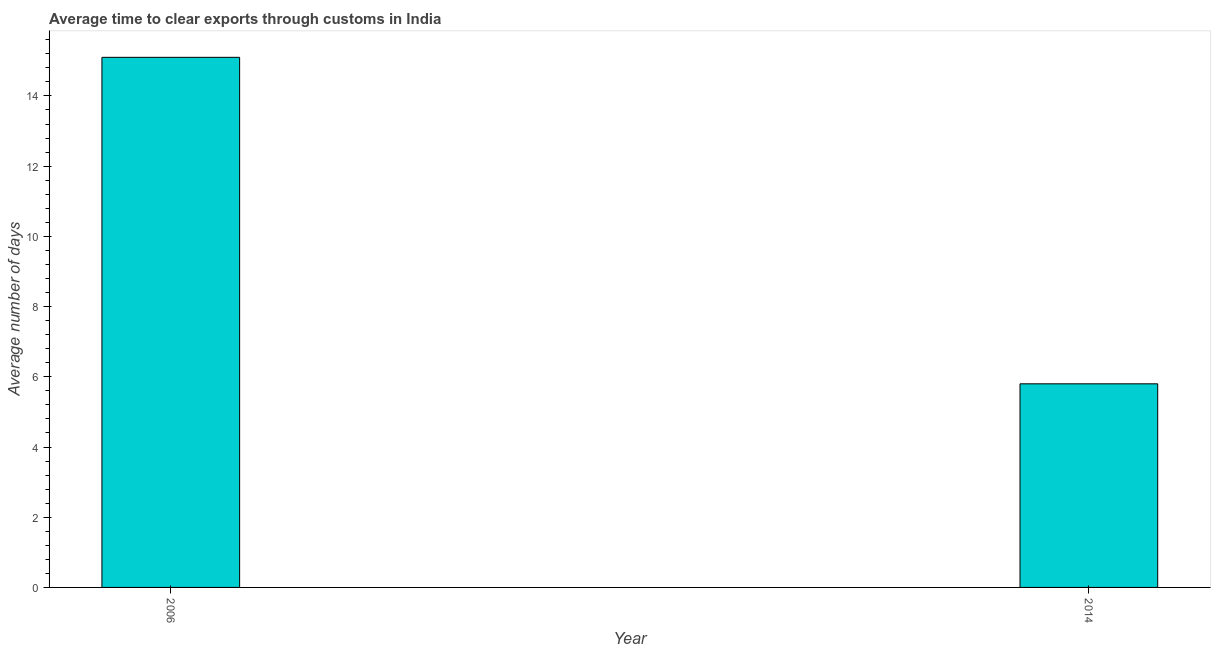Does the graph contain any zero values?
Your response must be concise. No. What is the title of the graph?
Your answer should be very brief. Average time to clear exports through customs in India. What is the label or title of the X-axis?
Keep it short and to the point. Year. What is the label or title of the Y-axis?
Your answer should be very brief. Average number of days. In which year was the time to clear exports through customs maximum?
Provide a succinct answer. 2006. In which year was the time to clear exports through customs minimum?
Offer a terse response. 2014. What is the sum of the time to clear exports through customs?
Your answer should be compact. 20.9. What is the difference between the time to clear exports through customs in 2006 and 2014?
Make the answer very short. 9.3. What is the average time to clear exports through customs per year?
Offer a very short reply. 10.45. What is the median time to clear exports through customs?
Offer a terse response. 10.45. In how many years, is the time to clear exports through customs greater than 12 days?
Ensure brevity in your answer.  1. What is the ratio of the time to clear exports through customs in 2006 to that in 2014?
Offer a very short reply. 2.6. Are all the bars in the graph horizontal?
Offer a terse response. No. Are the values on the major ticks of Y-axis written in scientific E-notation?
Make the answer very short. No. What is the Average number of days in 2006?
Offer a terse response. 15.1. What is the difference between the Average number of days in 2006 and 2014?
Make the answer very short. 9.3. What is the ratio of the Average number of days in 2006 to that in 2014?
Offer a terse response. 2.6. 